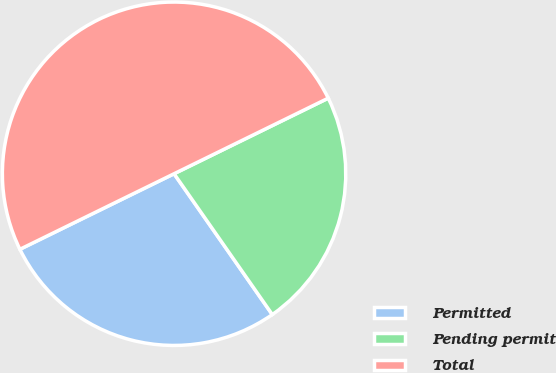Convert chart to OTSL. <chart><loc_0><loc_0><loc_500><loc_500><pie_chart><fcel>Permitted<fcel>Pending permit<fcel>Total<nl><fcel>27.44%<fcel>22.56%<fcel>50.0%<nl></chart> 